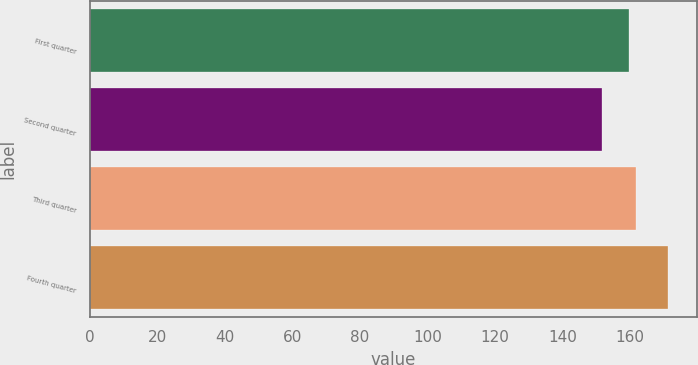<chart> <loc_0><loc_0><loc_500><loc_500><bar_chart><fcel>First quarter<fcel>Second quarter<fcel>Third quarter<fcel>Fourth quarter<nl><fcel>159.77<fcel>151.65<fcel>161.73<fcel>171.26<nl></chart> 